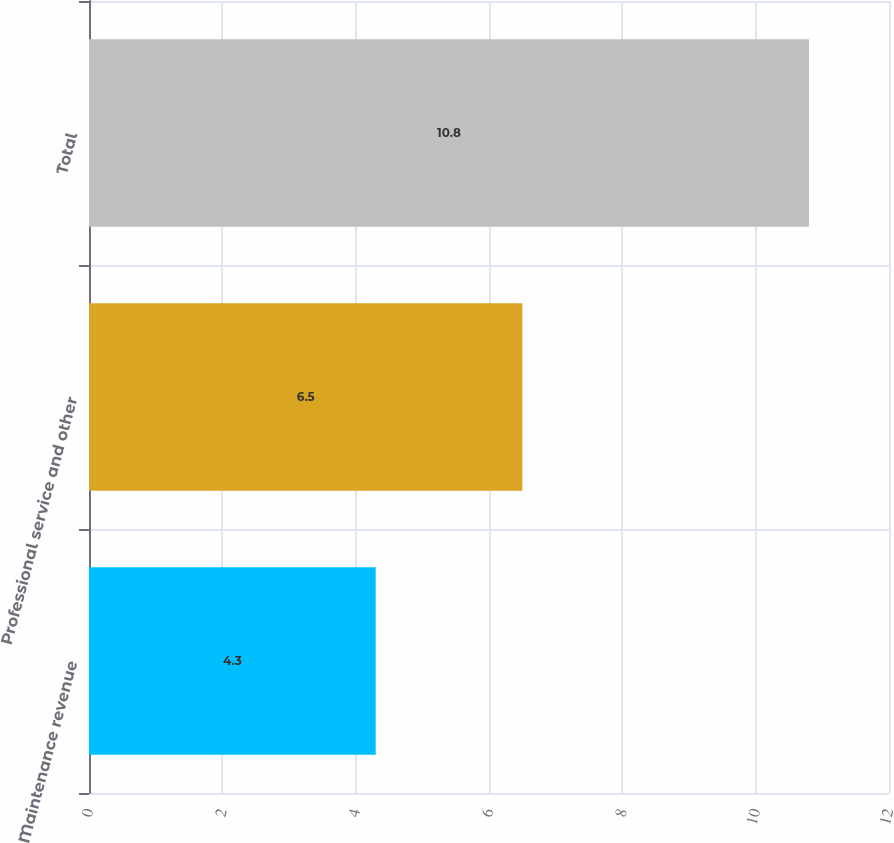<chart> <loc_0><loc_0><loc_500><loc_500><bar_chart><fcel>Maintenance revenue<fcel>Professional service and other<fcel>Total<nl><fcel>4.3<fcel>6.5<fcel>10.8<nl></chart> 